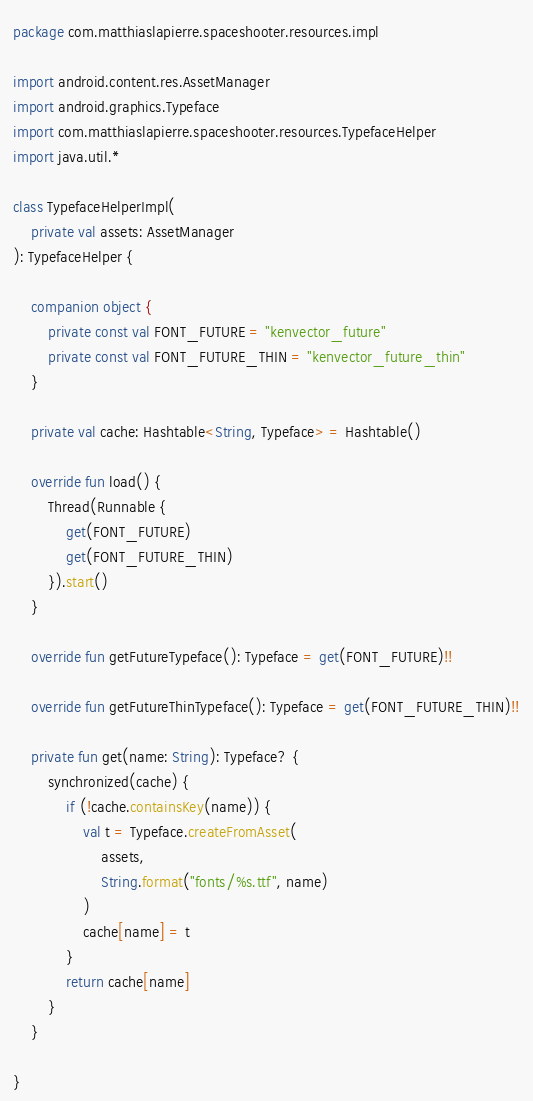Convert code to text. <code><loc_0><loc_0><loc_500><loc_500><_Kotlin_>package com.matthiaslapierre.spaceshooter.resources.impl

import android.content.res.AssetManager
import android.graphics.Typeface
import com.matthiaslapierre.spaceshooter.resources.TypefaceHelper
import java.util.*

class TypefaceHelperImpl(
    private val assets: AssetManager
): TypefaceHelper {

    companion object {
        private const val FONT_FUTURE = "kenvector_future"
        private const val FONT_FUTURE_THIN = "kenvector_future_thin"
    }

    private val cache: Hashtable<String, Typeface> = Hashtable()

    override fun load() {
        Thread(Runnable {
            get(FONT_FUTURE)
            get(FONT_FUTURE_THIN)
        }).start()
    }

    override fun getFutureTypeface(): Typeface = get(FONT_FUTURE)!!

    override fun getFutureThinTypeface(): Typeface = get(FONT_FUTURE_THIN)!!

    private fun get(name: String): Typeface? {
        synchronized(cache) {
            if (!cache.containsKey(name)) {
                val t = Typeface.createFromAsset(
                    assets,
                    String.format("fonts/%s.ttf", name)
                )
                cache[name] = t
            }
            return cache[name]
        }
    }

}</code> 